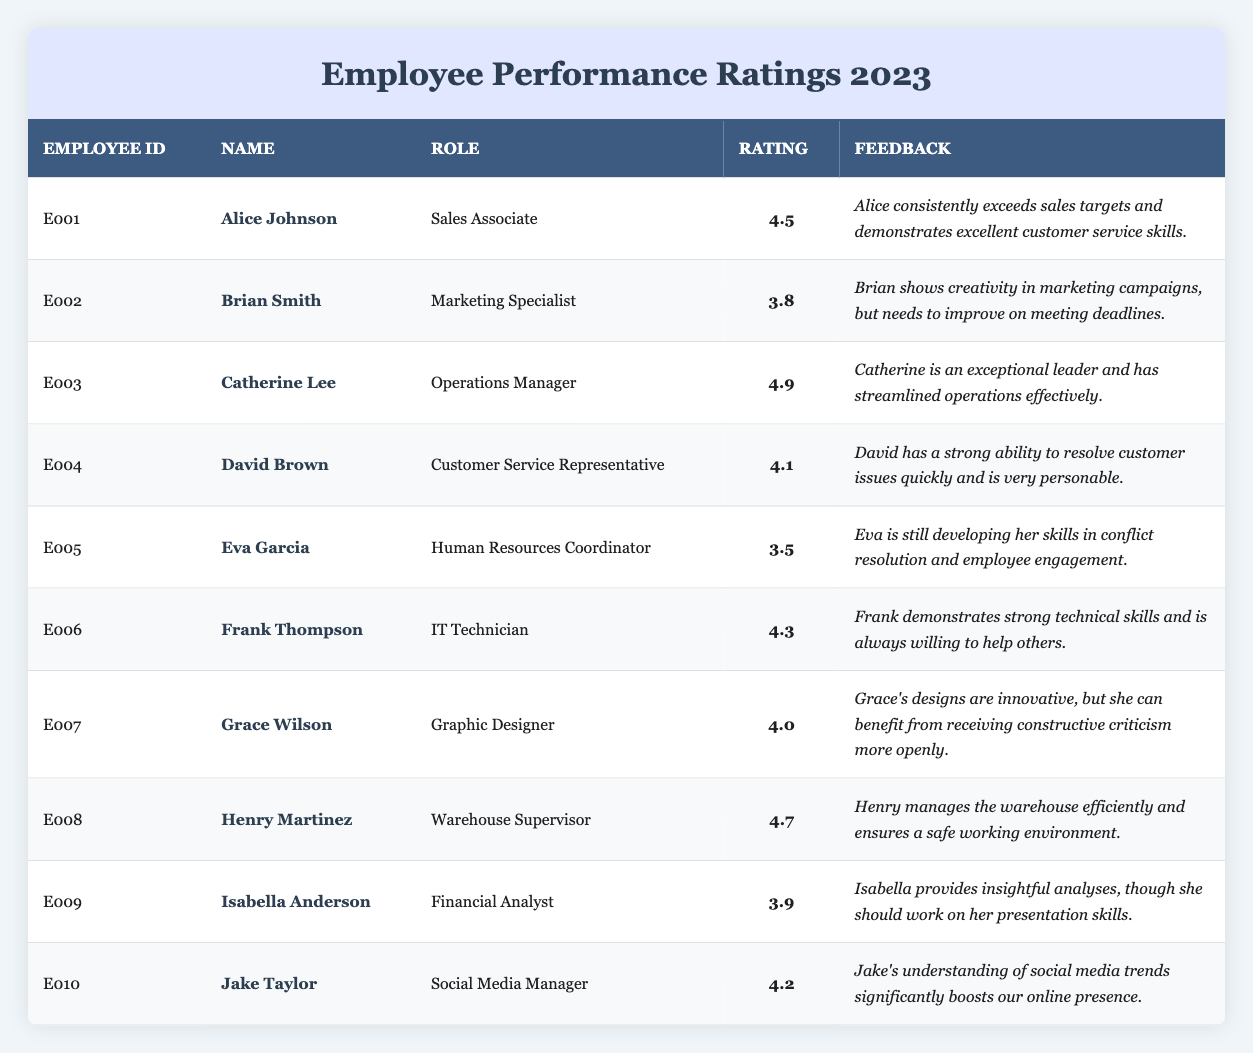What is the performance rating of Catherine Lee? The table lists Catherine Lee under Employee ID E003 with a performance rating of 4.9.
Answer: 4.9 Which employee has the highest performance rating? The highest performance rating listed in the table is 4.9 for Catherine Lee, who is the Operations Manager.
Answer: Catherine Lee How many employees have a performance rating of 4.0 or higher? By counting the ratings of all listed employees, we find that six employees have performance ratings of 4.0 or higher: Alice Johnson, Catherine Lee, David Brown, Frank Thompson, Henry Martinez, and Jake Taylor.
Answer: Six Is Eva Garcia's performance rating above the average rating of all employees? The average of the performance ratings (calculated as (4.5 + 3.8 + 4.9 + 4.1 + 3.5 + 4.3 + 4.0 + 4.7 + 3.9 + 4.2) / 10) is 4.2. Eva Garcia's rating is 3.5, which is below the average.
Answer: No What is the feedback for David Brown? The feedback provided for David Brown is that he has a strong ability to resolve customer issues quickly and is very personable.
Answer: Strong ability to resolve issues quickly How does Jake Taylor's performance rating compare to that of Frank Thompson? Jake Taylor has a performance rating of 4.2, while Frank Thompson has a rating of 4.3. Frank's rating is higher by 0.1 points.
Answer: Frank Thompson's rating is higher Calculate the difference between the highest and lowest performance ratings. The highest rating is 4.9 (Catherine Lee) and the lowest is 3.5 (Eva Garcia). The difference is 4.9 - 3.5 = 1.4.
Answer: 1.4 Which employees need to improve on specific skills according to their feedback? Eva Garcia is noted for developing conflict resolution and employee engagement skills, while Brian Smith needs to improve on meeting deadlines, and Isabella Anderson should work on her presentation skills.
Answer: Eva Garcia, Brian Smith, and Isabella Anderson Is Henry Martinez's role in the table associated with a performance rating of 4.7? Yes, the table indicates that Henry Martinez, who is the Warehouse Supervisor, has a performance rating of 4.7.
Answer: Yes 